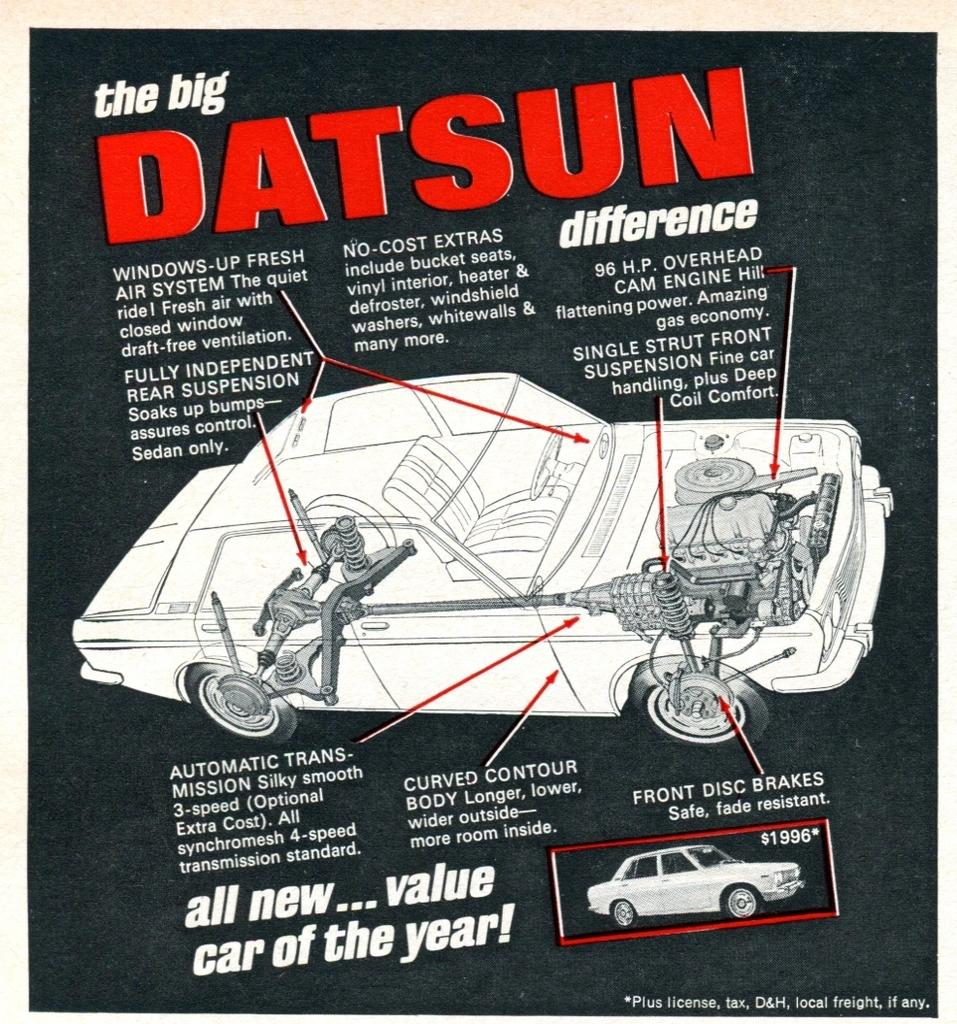What type of visual is the image in question? The image is a poster. What can be found on the poster besides the image? There is text on the poster. What is the main image depicted on the poster? There is an image of a car on the poster. What type of peace symbol can be seen on the poster? There is no peace symbol present on the poster; it features an image of a car and text. 